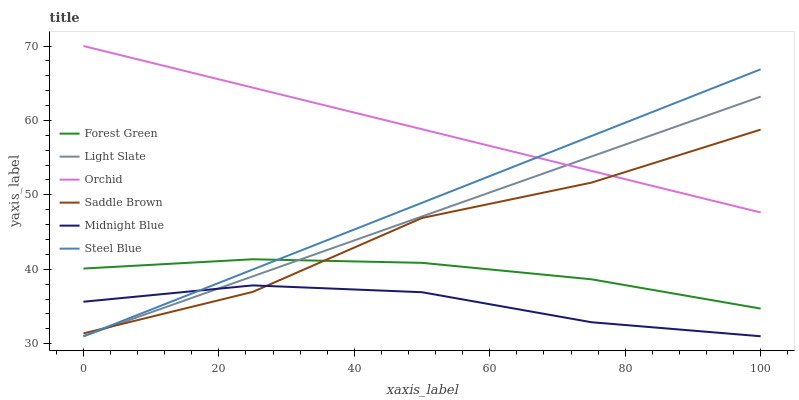Does Midnight Blue have the minimum area under the curve?
Answer yes or no. Yes. Does Orchid have the maximum area under the curve?
Answer yes or no. Yes. Does Light Slate have the minimum area under the curve?
Answer yes or no. No. Does Light Slate have the maximum area under the curve?
Answer yes or no. No. Is Orchid the smoothest?
Answer yes or no. Yes. Is Saddle Brown the roughest?
Answer yes or no. Yes. Is Light Slate the smoothest?
Answer yes or no. No. Is Light Slate the roughest?
Answer yes or no. No. Does Midnight Blue have the lowest value?
Answer yes or no. Yes. Does Forest Green have the lowest value?
Answer yes or no. No. Does Orchid have the highest value?
Answer yes or no. Yes. Does Light Slate have the highest value?
Answer yes or no. No. Is Forest Green less than Orchid?
Answer yes or no. Yes. Is Orchid greater than Midnight Blue?
Answer yes or no. Yes. Does Steel Blue intersect Orchid?
Answer yes or no. Yes. Is Steel Blue less than Orchid?
Answer yes or no. No. Is Steel Blue greater than Orchid?
Answer yes or no. No. Does Forest Green intersect Orchid?
Answer yes or no. No. 